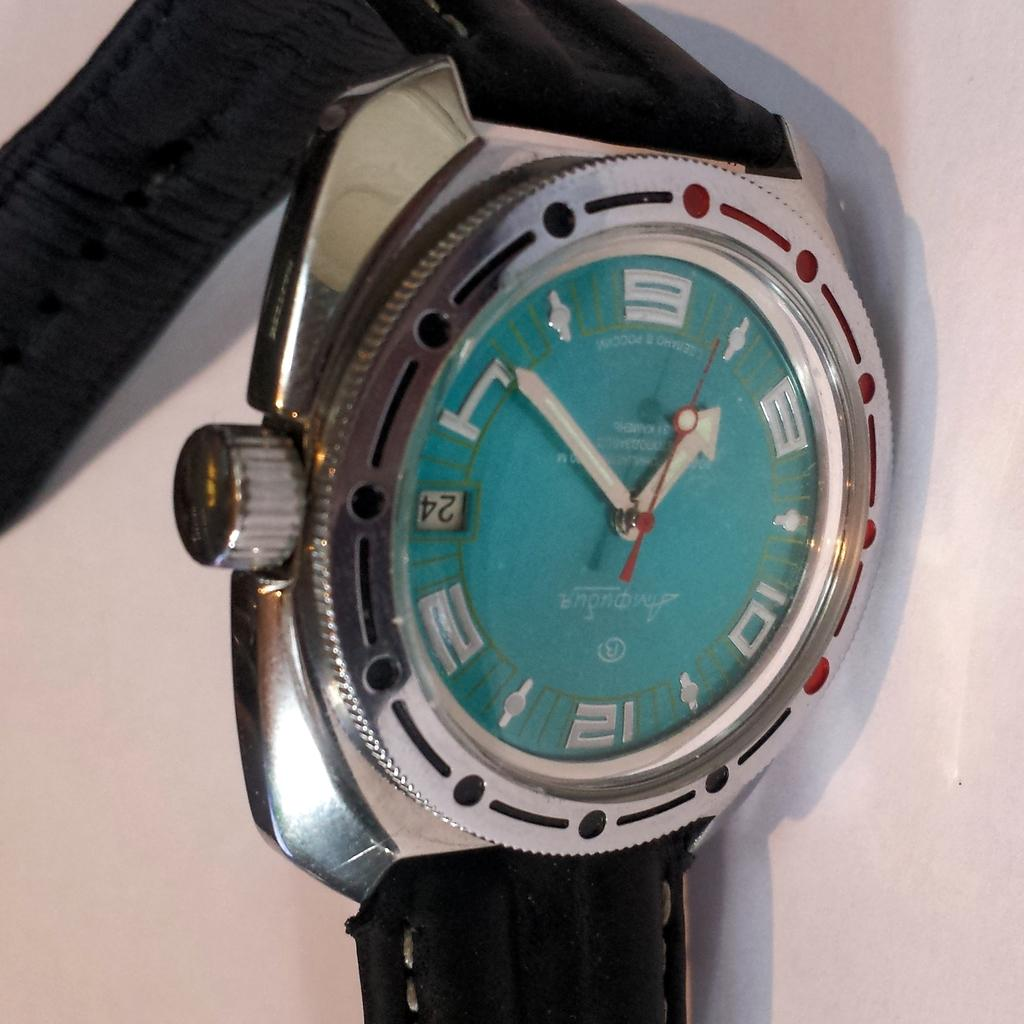<image>
Summarize the visual content of the image. A blue watch shows the digital number "24" seconds on the side. 